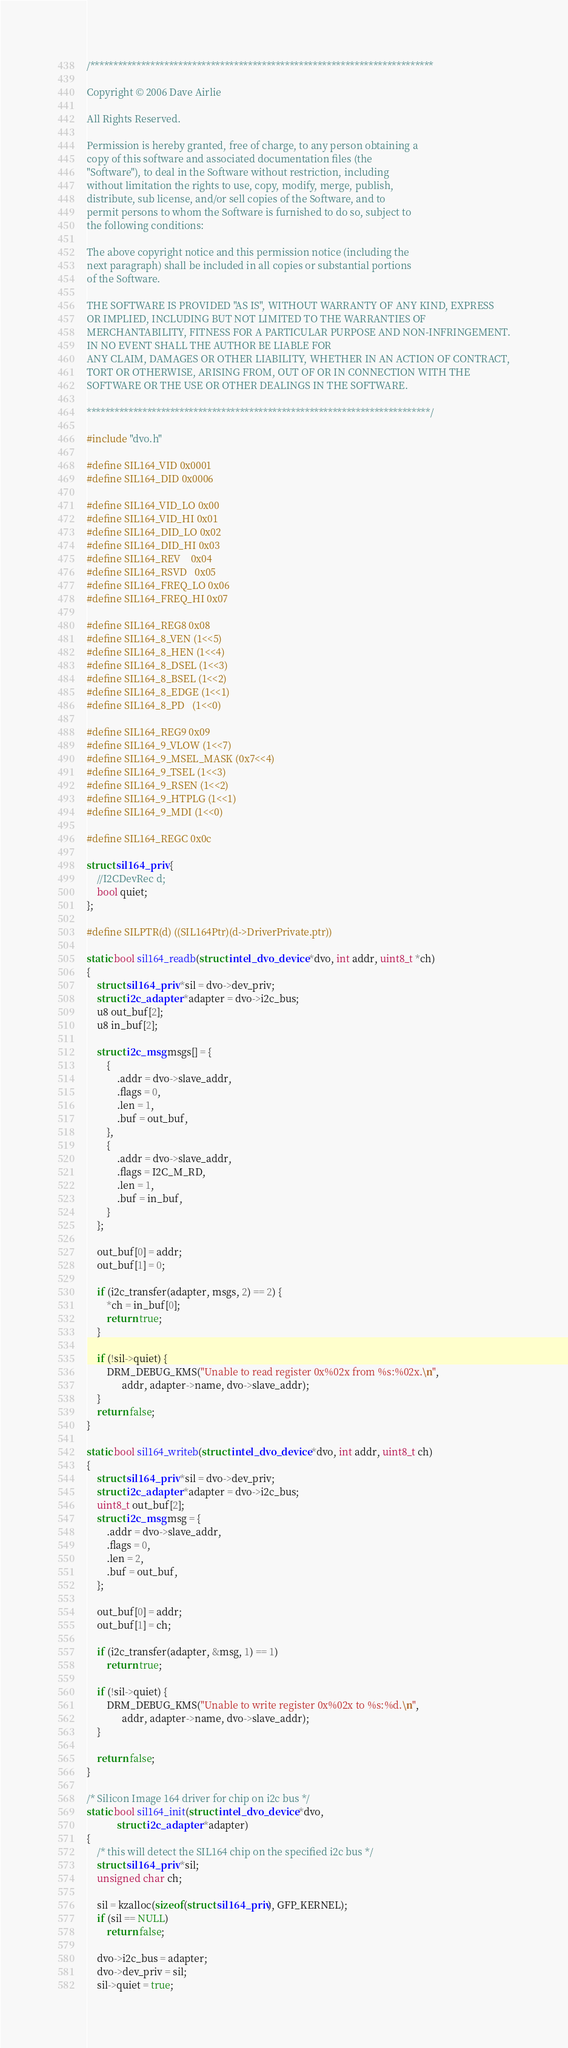Convert code to text. <code><loc_0><loc_0><loc_500><loc_500><_C_>/**************************************************************************

Copyright © 2006 Dave Airlie

All Rights Reserved.

Permission is hereby granted, free of charge, to any person obtaining a
copy of this software and associated documentation files (the
"Software"), to deal in the Software without restriction, including
without limitation the rights to use, copy, modify, merge, publish,
distribute, sub license, and/or sell copies of the Software, and to
permit persons to whom the Software is furnished to do so, subject to
the following conditions:

The above copyright notice and this permission notice (including the
next paragraph) shall be included in all copies or substantial portions
of the Software.

THE SOFTWARE IS PROVIDED "AS IS", WITHOUT WARRANTY OF ANY KIND, EXPRESS
OR IMPLIED, INCLUDING BUT NOT LIMITED TO THE WARRANTIES OF
MERCHANTABILITY, FITNESS FOR A PARTICULAR PURPOSE AND NON-INFRINGEMENT.
IN NO EVENT SHALL THE AUTHOR BE LIABLE FOR
ANY CLAIM, DAMAGES OR OTHER LIABILITY, WHETHER IN AN ACTION OF CONTRACT,
TORT OR OTHERWISE, ARISING FROM, OUT OF OR IN CONNECTION WITH THE
SOFTWARE OR THE USE OR OTHER DEALINGS IN THE SOFTWARE.

**************************************************************************/

#include "dvo.h"

#define SIL164_VID 0x0001
#define SIL164_DID 0x0006

#define SIL164_VID_LO 0x00
#define SIL164_VID_HI 0x01
#define SIL164_DID_LO 0x02
#define SIL164_DID_HI 0x03
#define SIL164_REV    0x04
#define SIL164_RSVD   0x05
#define SIL164_FREQ_LO 0x06
#define SIL164_FREQ_HI 0x07

#define SIL164_REG8 0x08
#define SIL164_8_VEN (1<<5)
#define SIL164_8_HEN (1<<4)
#define SIL164_8_DSEL (1<<3)
#define SIL164_8_BSEL (1<<2)
#define SIL164_8_EDGE (1<<1)
#define SIL164_8_PD   (1<<0)

#define SIL164_REG9 0x09
#define SIL164_9_VLOW (1<<7)
#define SIL164_9_MSEL_MASK (0x7<<4)
#define SIL164_9_TSEL (1<<3)
#define SIL164_9_RSEN (1<<2)
#define SIL164_9_HTPLG (1<<1)
#define SIL164_9_MDI (1<<0)

#define SIL164_REGC 0x0c

struct sil164_priv {
	//I2CDevRec d;
	bool quiet;
};

#define SILPTR(d) ((SIL164Ptr)(d->DriverPrivate.ptr))

static bool sil164_readb(struct intel_dvo_device *dvo, int addr, uint8_t *ch)
{
	struct sil164_priv *sil = dvo->dev_priv;
	struct i2c_adapter *adapter = dvo->i2c_bus;
	u8 out_buf[2];
	u8 in_buf[2];

	struct i2c_msg msgs[] = {
		{
			.addr = dvo->slave_addr,
			.flags = 0,
			.len = 1,
			.buf = out_buf,
		},
		{
			.addr = dvo->slave_addr,
			.flags = I2C_M_RD,
			.len = 1,
			.buf = in_buf,
		}
	};

	out_buf[0] = addr;
	out_buf[1] = 0;

	if (i2c_transfer(adapter, msgs, 2) == 2) {
		*ch = in_buf[0];
		return true;
	}

	if (!sil->quiet) {
		DRM_DEBUG_KMS("Unable to read register 0x%02x from %s:%02x.\n",
			  addr, adapter->name, dvo->slave_addr);
	}
	return false;
}

static bool sil164_writeb(struct intel_dvo_device *dvo, int addr, uint8_t ch)
{
	struct sil164_priv *sil = dvo->dev_priv;
	struct i2c_adapter *adapter = dvo->i2c_bus;
	uint8_t out_buf[2];
	struct i2c_msg msg = {
		.addr = dvo->slave_addr,
		.flags = 0,
		.len = 2,
		.buf = out_buf,
	};

	out_buf[0] = addr;
	out_buf[1] = ch;

	if (i2c_transfer(adapter, &msg, 1) == 1)
		return true;

	if (!sil->quiet) {
		DRM_DEBUG_KMS("Unable to write register 0x%02x to %s:%d.\n",
			  addr, adapter->name, dvo->slave_addr);
	}

	return false;
}

/* Silicon Image 164 driver for chip on i2c bus */
static bool sil164_init(struct intel_dvo_device *dvo,
			struct i2c_adapter *adapter)
{
	/* this will detect the SIL164 chip on the specified i2c bus */
	struct sil164_priv *sil;
	unsigned char ch;

	sil = kzalloc(sizeof(struct sil164_priv), GFP_KERNEL);
	if (sil == NULL)
		return false;

	dvo->i2c_bus = adapter;
	dvo->dev_priv = sil;
	sil->quiet = true;
</code> 